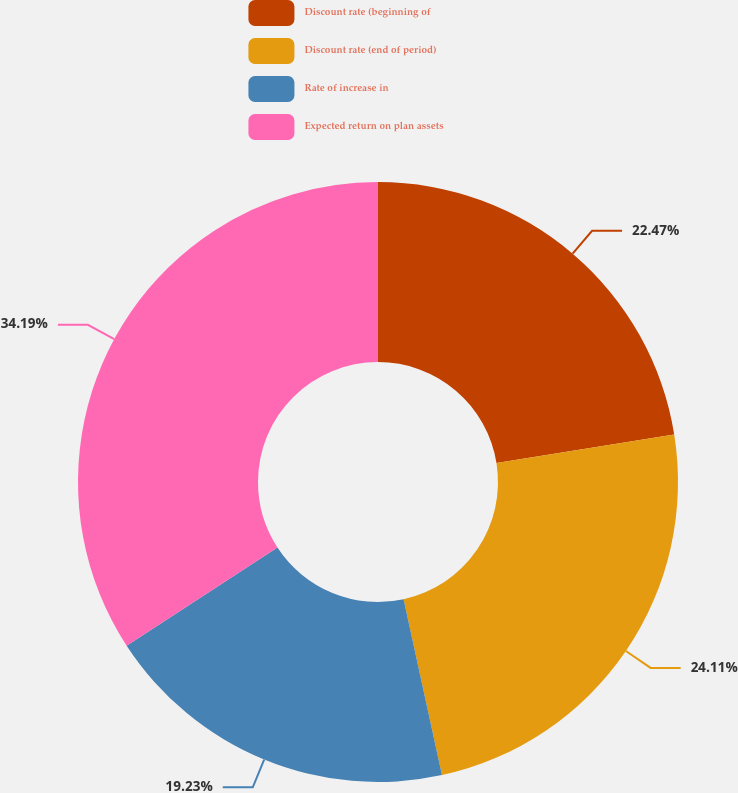<chart> <loc_0><loc_0><loc_500><loc_500><pie_chart><fcel>Discount rate (beginning of<fcel>Discount rate (end of period)<fcel>Rate of increase in<fcel>Expected return on plan assets<nl><fcel>22.47%<fcel>24.11%<fcel>19.23%<fcel>34.19%<nl></chart> 